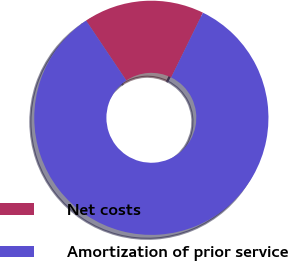Convert chart to OTSL. <chart><loc_0><loc_0><loc_500><loc_500><pie_chart><fcel>Net costs<fcel>Amortization of prior service<nl><fcel>16.67%<fcel>83.33%<nl></chart> 